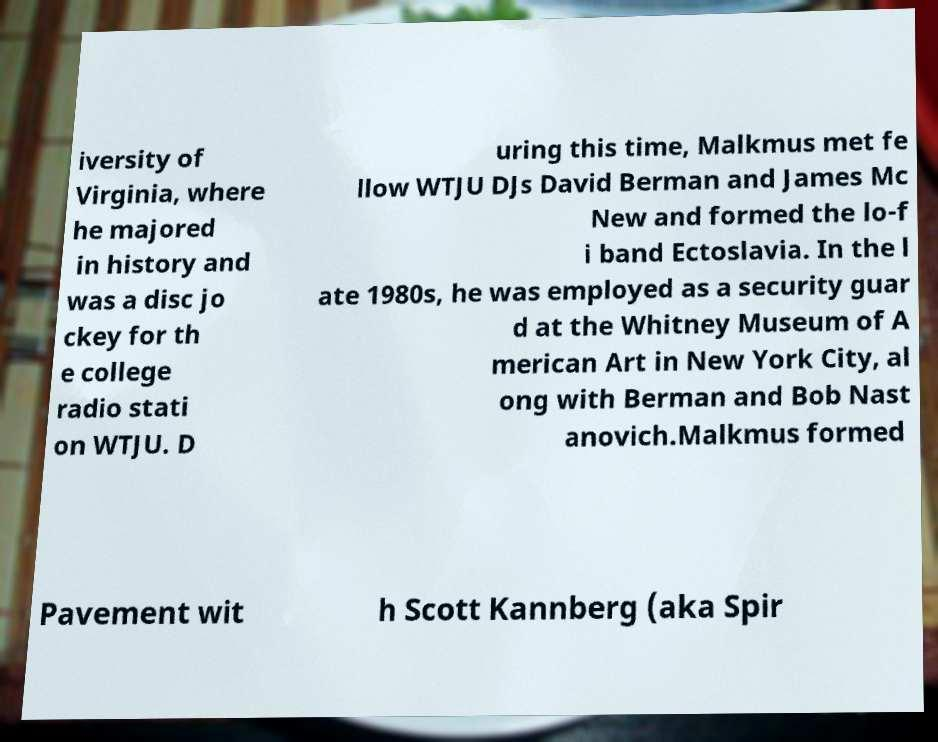Could you assist in decoding the text presented in this image and type it out clearly? iversity of Virginia, where he majored in history and was a disc jo ckey for th e college radio stati on WTJU. D uring this time, Malkmus met fe llow WTJU DJs David Berman and James Mc New and formed the lo-f i band Ectoslavia. In the l ate 1980s, he was employed as a security guar d at the Whitney Museum of A merican Art in New York City, al ong with Berman and Bob Nast anovich.Malkmus formed Pavement wit h Scott Kannberg (aka Spir 